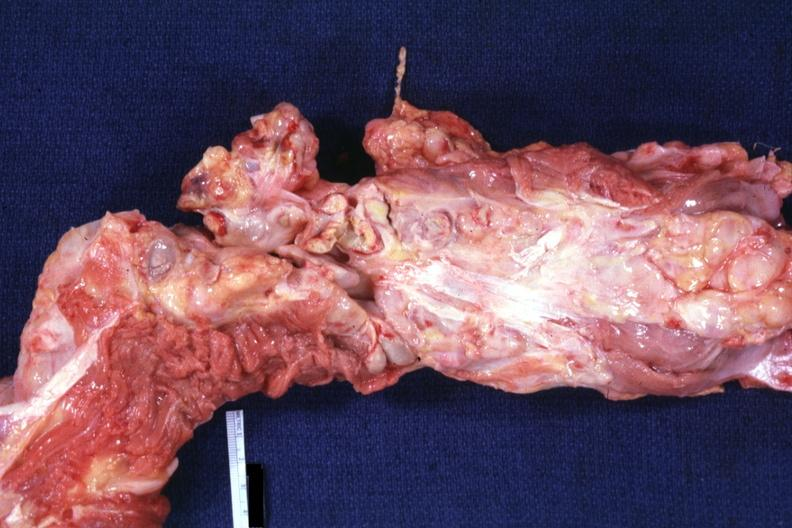how is aorta not opened surrounded by nodes?
Answer the question using a single word or phrase. Large 